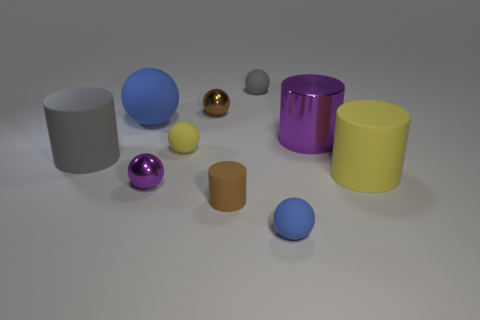Subtract 3 balls. How many balls are left? 3 Subtract all tiny brown balls. How many balls are left? 5 Subtract all purple spheres. How many spheres are left? 5 Subtract all purple spheres. Subtract all green cylinders. How many spheres are left? 5 Subtract all balls. How many objects are left? 4 Subtract all yellow matte cylinders. Subtract all big purple metallic objects. How many objects are left? 8 Add 2 gray things. How many gray things are left? 4 Add 6 tiny gray balls. How many tiny gray balls exist? 7 Subtract 0 brown cubes. How many objects are left? 10 